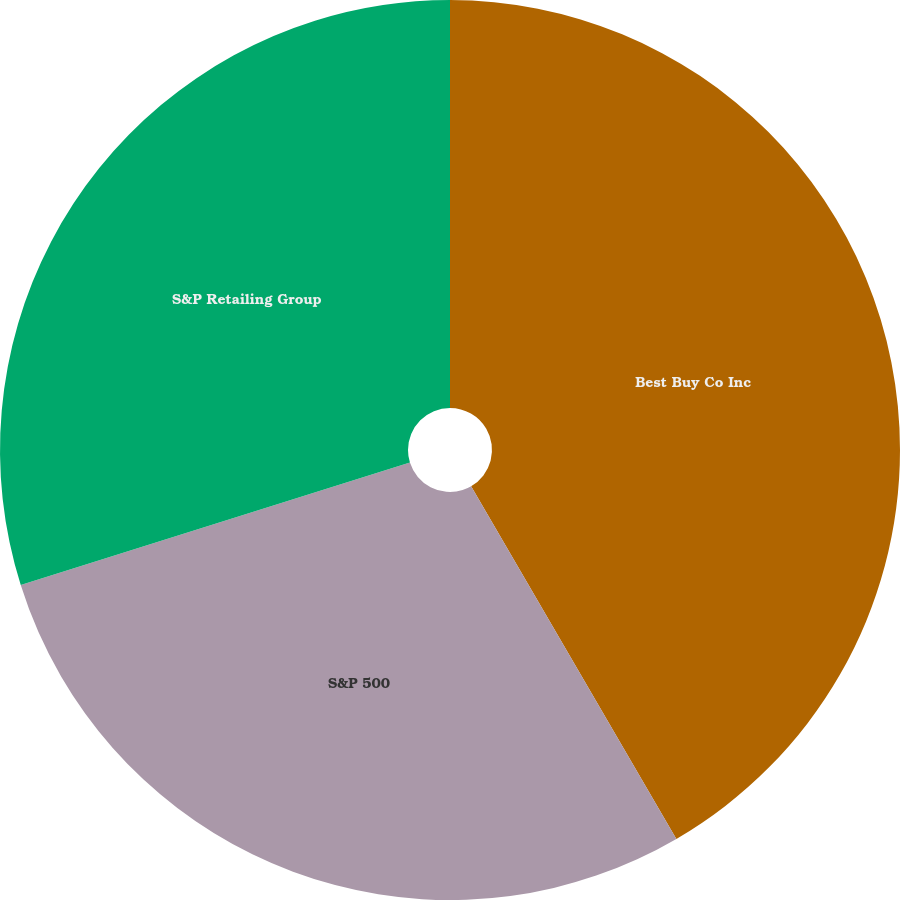Convert chart. <chart><loc_0><loc_0><loc_500><loc_500><pie_chart><fcel>Best Buy Co Inc<fcel>S&P 500<fcel>S&P Retailing Group<nl><fcel>41.61%<fcel>28.54%<fcel>29.85%<nl></chart> 